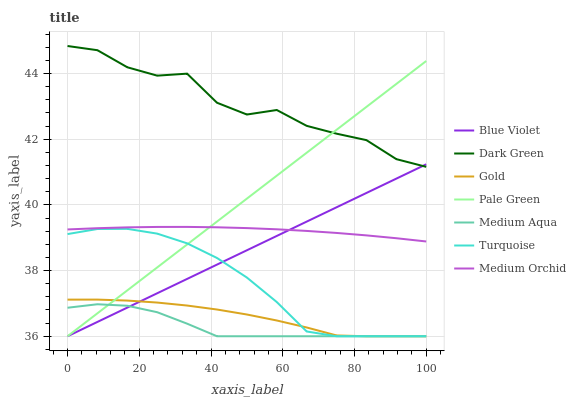Does Medium Aqua have the minimum area under the curve?
Answer yes or no. Yes. Does Dark Green have the maximum area under the curve?
Answer yes or no. Yes. Does Gold have the minimum area under the curve?
Answer yes or no. No. Does Gold have the maximum area under the curve?
Answer yes or no. No. Is Blue Violet the smoothest?
Answer yes or no. Yes. Is Dark Green the roughest?
Answer yes or no. Yes. Is Gold the smoothest?
Answer yes or no. No. Is Gold the roughest?
Answer yes or no. No. Does Turquoise have the lowest value?
Answer yes or no. Yes. Does Medium Orchid have the lowest value?
Answer yes or no. No. Does Dark Green have the highest value?
Answer yes or no. Yes. Does Gold have the highest value?
Answer yes or no. No. Is Turquoise less than Medium Orchid?
Answer yes or no. Yes. Is Dark Green greater than Medium Aqua?
Answer yes or no. Yes. Does Medium Aqua intersect Turquoise?
Answer yes or no. Yes. Is Medium Aqua less than Turquoise?
Answer yes or no. No. Is Medium Aqua greater than Turquoise?
Answer yes or no. No. Does Turquoise intersect Medium Orchid?
Answer yes or no. No. 